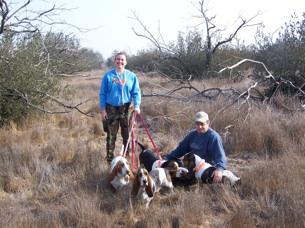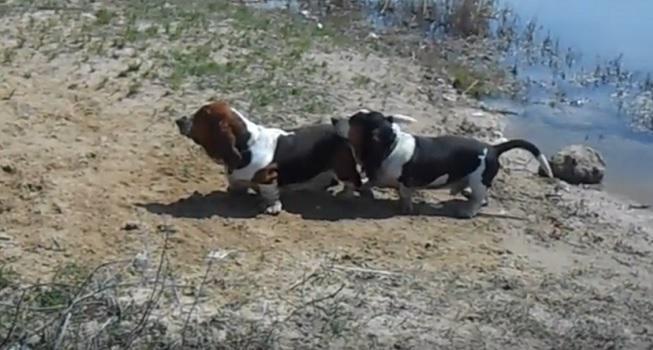The first image is the image on the left, the second image is the image on the right. Evaluate the accuracy of this statement regarding the images: "One image contains two basset hounds and no humans, and the other image includes at least one person with multiple basset hounds on leashes.". Is it true? Answer yes or no. Yes. The first image is the image on the left, the second image is the image on the right. Given the left and right images, does the statement "One picture has atleast 2 dogs and a person." hold true? Answer yes or no. Yes. 